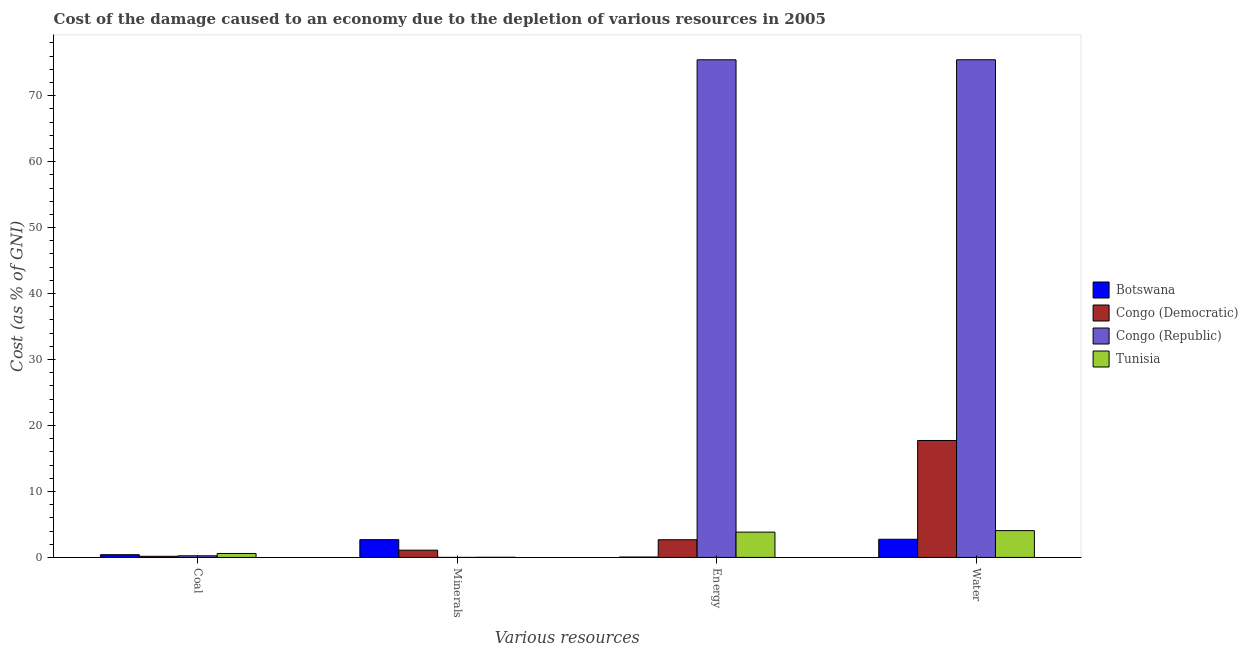Are the number of bars on each tick of the X-axis equal?
Offer a terse response. Yes. How many bars are there on the 1st tick from the left?
Provide a short and direct response. 4. What is the label of the 4th group of bars from the left?
Ensure brevity in your answer.  Water. What is the cost of damage due to depletion of energy in Botswana?
Your answer should be very brief. 0.06. Across all countries, what is the maximum cost of damage due to depletion of minerals?
Give a very brief answer. 2.69. Across all countries, what is the minimum cost of damage due to depletion of coal?
Your answer should be compact. 0.18. In which country was the cost of damage due to depletion of coal maximum?
Your answer should be compact. Tunisia. In which country was the cost of damage due to depletion of minerals minimum?
Give a very brief answer. Congo (Republic). What is the total cost of damage due to depletion of energy in the graph?
Make the answer very short. 82.02. What is the difference between the cost of damage due to depletion of minerals in Congo (Republic) and that in Congo (Democratic)?
Provide a succinct answer. -1.09. What is the difference between the cost of damage due to depletion of coal in Congo (Republic) and the cost of damage due to depletion of water in Botswana?
Make the answer very short. -2.5. What is the average cost of damage due to depletion of minerals per country?
Offer a terse response. 0.95. What is the difference between the cost of damage due to depletion of water and cost of damage due to depletion of energy in Tunisia?
Make the answer very short. 0.23. In how many countries, is the cost of damage due to depletion of energy greater than 44 %?
Your response must be concise. 1. What is the ratio of the cost of damage due to depletion of minerals in Congo (Republic) to that in Congo (Democratic)?
Offer a terse response. 0. Is the cost of damage due to depletion of water in Botswana less than that in Congo (Republic)?
Your response must be concise. Yes. What is the difference between the highest and the second highest cost of damage due to depletion of minerals?
Keep it short and to the point. 1.59. What is the difference between the highest and the lowest cost of damage due to depletion of energy?
Give a very brief answer. 75.38. Is the sum of the cost of damage due to depletion of water in Tunisia and Botswana greater than the maximum cost of damage due to depletion of coal across all countries?
Offer a terse response. Yes. What does the 1st bar from the left in Minerals represents?
Ensure brevity in your answer.  Botswana. What does the 3rd bar from the right in Energy represents?
Give a very brief answer. Congo (Democratic). How many bars are there?
Keep it short and to the point. 16. Are all the bars in the graph horizontal?
Offer a terse response. No. What is the difference between two consecutive major ticks on the Y-axis?
Your answer should be compact. 10. Where does the legend appear in the graph?
Your answer should be very brief. Center right. How many legend labels are there?
Ensure brevity in your answer.  4. What is the title of the graph?
Provide a short and direct response. Cost of the damage caused to an economy due to the depletion of various resources in 2005 . What is the label or title of the X-axis?
Your answer should be compact. Various resources. What is the label or title of the Y-axis?
Give a very brief answer. Cost (as % of GNI). What is the Cost (as % of GNI) in Botswana in Coal?
Your answer should be very brief. 0.41. What is the Cost (as % of GNI) in Congo (Democratic) in Coal?
Your answer should be very brief. 0.18. What is the Cost (as % of GNI) in Congo (Republic) in Coal?
Ensure brevity in your answer.  0.25. What is the Cost (as % of GNI) of Tunisia in Coal?
Ensure brevity in your answer.  0.6. What is the Cost (as % of GNI) in Botswana in Minerals?
Give a very brief answer. 2.69. What is the Cost (as % of GNI) in Congo (Democratic) in Minerals?
Your response must be concise. 1.1. What is the Cost (as % of GNI) of Congo (Republic) in Minerals?
Your response must be concise. 0. What is the Cost (as % of GNI) in Tunisia in Minerals?
Your response must be concise. 0.02. What is the Cost (as % of GNI) in Botswana in Energy?
Offer a very short reply. 0.06. What is the Cost (as % of GNI) of Congo (Democratic) in Energy?
Provide a succinct answer. 2.68. What is the Cost (as % of GNI) in Congo (Republic) in Energy?
Provide a succinct answer. 75.44. What is the Cost (as % of GNI) of Tunisia in Energy?
Your answer should be compact. 3.84. What is the Cost (as % of GNI) of Botswana in Water?
Offer a terse response. 2.75. What is the Cost (as % of GNI) of Congo (Democratic) in Water?
Offer a very short reply. 17.73. What is the Cost (as % of GNI) of Congo (Republic) in Water?
Offer a terse response. 75.44. What is the Cost (as % of GNI) in Tunisia in Water?
Ensure brevity in your answer.  4.06. Across all Various resources, what is the maximum Cost (as % of GNI) of Botswana?
Provide a short and direct response. 2.75. Across all Various resources, what is the maximum Cost (as % of GNI) in Congo (Democratic)?
Ensure brevity in your answer.  17.73. Across all Various resources, what is the maximum Cost (as % of GNI) of Congo (Republic)?
Your answer should be very brief. 75.44. Across all Various resources, what is the maximum Cost (as % of GNI) of Tunisia?
Your response must be concise. 4.06. Across all Various resources, what is the minimum Cost (as % of GNI) of Botswana?
Make the answer very short. 0.06. Across all Various resources, what is the minimum Cost (as % of GNI) in Congo (Democratic)?
Your answer should be very brief. 0.18. Across all Various resources, what is the minimum Cost (as % of GNI) in Congo (Republic)?
Your response must be concise. 0. Across all Various resources, what is the minimum Cost (as % of GNI) of Tunisia?
Provide a succinct answer. 0.02. What is the total Cost (as % of GNI) of Botswana in the graph?
Give a very brief answer. 5.91. What is the total Cost (as % of GNI) of Congo (Democratic) in the graph?
Your response must be concise. 21.68. What is the total Cost (as % of GNI) of Congo (Republic) in the graph?
Your response must be concise. 151.14. What is the total Cost (as % of GNI) of Tunisia in the graph?
Provide a short and direct response. 8.52. What is the difference between the Cost (as % of GNI) in Botswana in Coal and that in Minerals?
Provide a succinct answer. -2.28. What is the difference between the Cost (as % of GNI) of Congo (Democratic) in Coal and that in Minerals?
Your answer should be compact. -0.92. What is the difference between the Cost (as % of GNI) of Congo (Republic) in Coal and that in Minerals?
Make the answer very short. 0.24. What is the difference between the Cost (as % of GNI) in Tunisia in Coal and that in Minerals?
Keep it short and to the point. 0.58. What is the difference between the Cost (as % of GNI) of Botswana in Coal and that in Energy?
Give a very brief answer. 0.35. What is the difference between the Cost (as % of GNI) in Congo (Democratic) in Coal and that in Energy?
Provide a short and direct response. -2.5. What is the difference between the Cost (as % of GNI) in Congo (Republic) in Coal and that in Energy?
Your answer should be compact. -75.19. What is the difference between the Cost (as % of GNI) in Tunisia in Coal and that in Energy?
Provide a short and direct response. -3.24. What is the difference between the Cost (as % of GNI) in Botswana in Coal and that in Water?
Your answer should be very brief. -2.34. What is the difference between the Cost (as % of GNI) of Congo (Democratic) in Coal and that in Water?
Offer a very short reply. -17.55. What is the difference between the Cost (as % of GNI) in Congo (Republic) in Coal and that in Water?
Make the answer very short. -75.19. What is the difference between the Cost (as % of GNI) in Tunisia in Coal and that in Water?
Provide a short and direct response. -3.46. What is the difference between the Cost (as % of GNI) of Botswana in Minerals and that in Energy?
Keep it short and to the point. 2.63. What is the difference between the Cost (as % of GNI) of Congo (Democratic) in Minerals and that in Energy?
Provide a succinct answer. -1.58. What is the difference between the Cost (as % of GNI) in Congo (Republic) in Minerals and that in Energy?
Your response must be concise. -75.43. What is the difference between the Cost (as % of GNI) in Tunisia in Minerals and that in Energy?
Your answer should be very brief. -3.81. What is the difference between the Cost (as % of GNI) in Botswana in Minerals and that in Water?
Your answer should be compact. -0.06. What is the difference between the Cost (as % of GNI) of Congo (Democratic) in Minerals and that in Water?
Give a very brief answer. -16.63. What is the difference between the Cost (as % of GNI) of Congo (Republic) in Minerals and that in Water?
Provide a succinct answer. -75.44. What is the difference between the Cost (as % of GNI) in Tunisia in Minerals and that in Water?
Your answer should be very brief. -4.04. What is the difference between the Cost (as % of GNI) of Botswana in Energy and that in Water?
Offer a very short reply. -2.69. What is the difference between the Cost (as % of GNI) in Congo (Democratic) in Energy and that in Water?
Your answer should be very brief. -15.05. What is the difference between the Cost (as % of GNI) of Congo (Republic) in Energy and that in Water?
Offer a very short reply. -0. What is the difference between the Cost (as % of GNI) of Tunisia in Energy and that in Water?
Give a very brief answer. -0.23. What is the difference between the Cost (as % of GNI) of Botswana in Coal and the Cost (as % of GNI) of Congo (Democratic) in Minerals?
Keep it short and to the point. -0.69. What is the difference between the Cost (as % of GNI) of Botswana in Coal and the Cost (as % of GNI) of Congo (Republic) in Minerals?
Ensure brevity in your answer.  0.41. What is the difference between the Cost (as % of GNI) in Botswana in Coal and the Cost (as % of GNI) in Tunisia in Minerals?
Keep it short and to the point. 0.39. What is the difference between the Cost (as % of GNI) of Congo (Democratic) in Coal and the Cost (as % of GNI) of Congo (Republic) in Minerals?
Your answer should be compact. 0.17. What is the difference between the Cost (as % of GNI) of Congo (Democratic) in Coal and the Cost (as % of GNI) of Tunisia in Minerals?
Offer a terse response. 0.15. What is the difference between the Cost (as % of GNI) in Congo (Republic) in Coal and the Cost (as % of GNI) in Tunisia in Minerals?
Your answer should be compact. 0.23. What is the difference between the Cost (as % of GNI) in Botswana in Coal and the Cost (as % of GNI) in Congo (Democratic) in Energy?
Offer a terse response. -2.27. What is the difference between the Cost (as % of GNI) in Botswana in Coal and the Cost (as % of GNI) in Congo (Republic) in Energy?
Ensure brevity in your answer.  -75.03. What is the difference between the Cost (as % of GNI) in Botswana in Coal and the Cost (as % of GNI) in Tunisia in Energy?
Ensure brevity in your answer.  -3.43. What is the difference between the Cost (as % of GNI) of Congo (Democratic) in Coal and the Cost (as % of GNI) of Congo (Republic) in Energy?
Your answer should be compact. -75.26. What is the difference between the Cost (as % of GNI) in Congo (Democratic) in Coal and the Cost (as % of GNI) in Tunisia in Energy?
Provide a succinct answer. -3.66. What is the difference between the Cost (as % of GNI) in Congo (Republic) in Coal and the Cost (as % of GNI) in Tunisia in Energy?
Provide a succinct answer. -3.59. What is the difference between the Cost (as % of GNI) of Botswana in Coal and the Cost (as % of GNI) of Congo (Democratic) in Water?
Your answer should be very brief. -17.32. What is the difference between the Cost (as % of GNI) of Botswana in Coal and the Cost (as % of GNI) of Congo (Republic) in Water?
Provide a succinct answer. -75.03. What is the difference between the Cost (as % of GNI) in Botswana in Coal and the Cost (as % of GNI) in Tunisia in Water?
Your answer should be compact. -3.65. What is the difference between the Cost (as % of GNI) of Congo (Democratic) in Coal and the Cost (as % of GNI) of Congo (Republic) in Water?
Ensure brevity in your answer.  -75.27. What is the difference between the Cost (as % of GNI) of Congo (Democratic) in Coal and the Cost (as % of GNI) of Tunisia in Water?
Your answer should be very brief. -3.89. What is the difference between the Cost (as % of GNI) in Congo (Republic) in Coal and the Cost (as % of GNI) in Tunisia in Water?
Your response must be concise. -3.81. What is the difference between the Cost (as % of GNI) in Botswana in Minerals and the Cost (as % of GNI) in Congo (Democratic) in Energy?
Your answer should be very brief. 0.01. What is the difference between the Cost (as % of GNI) of Botswana in Minerals and the Cost (as % of GNI) of Congo (Republic) in Energy?
Offer a very short reply. -72.75. What is the difference between the Cost (as % of GNI) of Botswana in Minerals and the Cost (as % of GNI) of Tunisia in Energy?
Keep it short and to the point. -1.15. What is the difference between the Cost (as % of GNI) of Congo (Democratic) in Minerals and the Cost (as % of GNI) of Congo (Republic) in Energy?
Provide a short and direct response. -74.34. What is the difference between the Cost (as % of GNI) of Congo (Democratic) in Minerals and the Cost (as % of GNI) of Tunisia in Energy?
Give a very brief answer. -2.74. What is the difference between the Cost (as % of GNI) in Congo (Republic) in Minerals and the Cost (as % of GNI) in Tunisia in Energy?
Make the answer very short. -3.83. What is the difference between the Cost (as % of GNI) in Botswana in Minerals and the Cost (as % of GNI) in Congo (Democratic) in Water?
Make the answer very short. -15.04. What is the difference between the Cost (as % of GNI) in Botswana in Minerals and the Cost (as % of GNI) in Congo (Republic) in Water?
Your response must be concise. -72.75. What is the difference between the Cost (as % of GNI) in Botswana in Minerals and the Cost (as % of GNI) in Tunisia in Water?
Give a very brief answer. -1.37. What is the difference between the Cost (as % of GNI) of Congo (Democratic) in Minerals and the Cost (as % of GNI) of Congo (Republic) in Water?
Keep it short and to the point. -74.35. What is the difference between the Cost (as % of GNI) in Congo (Democratic) in Minerals and the Cost (as % of GNI) in Tunisia in Water?
Offer a very short reply. -2.97. What is the difference between the Cost (as % of GNI) in Congo (Republic) in Minerals and the Cost (as % of GNI) in Tunisia in Water?
Keep it short and to the point. -4.06. What is the difference between the Cost (as % of GNI) in Botswana in Energy and the Cost (as % of GNI) in Congo (Democratic) in Water?
Your answer should be very brief. -17.67. What is the difference between the Cost (as % of GNI) of Botswana in Energy and the Cost (as % of GNI) of Congo (Republic) in Water?
Provide a succinct answer. -75.38. What is the difference between the Cost (as % of GNI) of Botswana in Energy and the Cost (as % of GNI) of Tunisia in Water?
Ensure brevity in your answer.  -4. What is the difference between the Cost (as % of GNI) in Congo (Democratic) in Energy and the Cost (as % of GNI) in Congo (Republic) in Water?
Make the answer very short. -72.77. What is the difference between the Cost (as % of GNI) in Congo (Democratic) in Energy and the Cost (as % of GNI) in Tunisia in Water?
Provide a succinct answer. -1.38. What is the difference between the Cost (as % of GNI) of Congo (Republic) in Energy and the Cost (as % of GNI) of Tunisia in Water?
Your response must be concise. 71.38. What is the average Cost (as % of GNI) of Botswana per Various resources?
Your response must be concise. 1.48. What is the average Cost (as % of GNI) in Congo (Democratic) per Various resources?
Your answer should be compact. 5.42. What is the average Cost (as % of GNI) of Congo (Republic) per Various resources?
Your answer should be compact. 37.78. What is the average Cost (as % of GNI) of Tunisia per Various resources?
Provide a succinct answer. 2.13. What is the difference between the Cost (as % of GNI) in Botswana and Cost (as % of GNI) in Congo (Democratic) in Coal?
Offer a terse response. 0.24. What is the difference between the Cost (as % of GNI) of Botswana and Cost (as % of GNI) of Congo (Republic) in Coal?
Offer a terse response. 0.16. What is the difference between the Cost (as % of GNI) of Botswana and Cost (as % of GNI) of Tunisia in Coal?
Make the answer very short. -0.19. What is the difference between the Cost (as % of GNI) of Congo (Democratic) and Cost (as % of GNI) of Congo (Republic) in Coal?
Provide a succinct answer. -0.07. What is the difference between the Cost (as % of GNI) in Congo (Democratic) and Cost (as % of GNI) in Tunisia in Coal?
Keep it short and to the point. -0.42. What is the difference between the Cost (as % of GNI) in Congo (Republic) and Cost (as % of GNI) in Tunisia in Coal?
Keep it short and to the point. -0.35. What is the difference between the Cost (as % of GNI) of Botswana and Cost (as % of GNI) of Congo (Democratic) in Minerals?
Keep it short and to the point. 1.59. What is the difference between the Cost (as % of GNI) of Botswana and Cost (as % of GNI) of Congo (Republic) in Minerals?
Offer a very short reply. 2.69. What is the difference between the Cost (as % of GNI) in Botswana and Cost (as % of GNI) in Tunisia in Minerals?
Provide a short and direct response. 2.67. What is the difference between the Cost (as % of GNI) of Congo (Democratic) and Cost (as % of GNI) of Congo (Republic) in Minerals?
Offer a very short reply. 1.09. What is the difference between the Cost (as % of GNI) of Congo (Democratic) and Cost (as % of GNI) of Tunisia in Minerals?
Provide a short and direct response. 1.07. What is the difference between the Cost (as % of GNI) of Congo (Republic) and Cost (as % of GNI) of Tunisia in Minerals?
Offer a terse response. -0.02. What is the difference between the Cost (as % of GNI) of Botswana and Cost (as % of GNI) of Congo (Democratic) in Energy?
Your response must be concise. -2.62. What is the difference between the Cost (as % of GNI) of Botswana and Cost (as % of GNI) of Congo (Republic) in Energy?
Provide a short and direct response. -75.38. What is the difference between the Cost (as % of GNI) in Botswana and Cost (as % of GNI) in Tunisia in Energy?
Provide a succinct answer. -3.78. What is the difference between the Cost (as % of GNI) of Congo (Democratic) and Cost (as % of GNI) of Congo (Republic) in Energy?
Keep it short and to the point. -72.76. What is the difference between the Cost (as % of GNI) of Congo (Democratic) and Cost (as % of GNI) of Tunisia in Energy?
Offer a terse response. -1.16. What is the difference between the Cost (as % of GNI) of Congo (Republic) and Cost (as % of GNI) of Tunisia in Energy?
Your answer should be very brief. 71.6. What is the difference between the Cost (as % of GNI) in Botswana and Cost (as % of GNI) in Congo (Democratic) in Water?
Provide a short and direct response. -14.98. What is the difference between the Cost (as % of GNI) in Botswana and Cost (as % of GNI) in Congo (Republic) in Water?
Keep it short and to the point. -72.69. What is the difference between the Cost (as % of GNI) of Botswana and Cost (as % of GNI) of Tunisia in Water?
Provide a succinct answer. -1.31. What is the difference between the Cost (as % of GNI) in Congo (Democratic) and Cost (as % of GNI) in Congo (Republic) in Water?
Keep it short and to the point. -57.72. What is the difference between the Cost (as % of GNI) in Congo (Democratic) and Cost (as % of GNI) in Tunisia in Water?
Your answer should be very brief. 13.66. What is the difference between the Cost (as % of GNI) in Congo (Republic) and Cost (as % of GNI) in Tunisia in Water?
Give a very brief answer. 71.38. What is the ratio of the Cost (as % of GNI) in Botswana in Coal to that in Minerals?
Make the answer very short. 0.15. What is the ratio of the Cost (as % of GNI) of Congo (Democratic) in Coal to that in Minerals?
Offer a very short reply. 0.16. What is the ratio of the Cost (as % of GNI) of Congo (Republic) in Coal to that in Minerals?
Provide a short and direct response. 52.63. What is the ratio of the Cost (as % of GNI) of Tunisia in Coal to that in Minerals?
Your answer should be very brief. 26.46. What is the ratio of the Cost (as % of GNI) of Botswana in Coal to that in Energy?
Keep it short and to the point. 6.76. What is the ratio of the Cost (as % of GNI) in Congo (Democratic) in Coal to that in Energy?
Your response must be concise. 0.07. What is the ratio of the Cost (as % of GNI) in Congo (Republic) in Coal to that in Energy?
Make the answer very short. 0. What is the ratio of the Cost (as % of GNI) of Tunisia in Coal to that in Energy?
Provide a succinct answer. 0.16. What is the ratio of the Cost (as % of GNI) of Botswana in Coal to that in Water?
Make the answer very short. 0.15. What is the ratio of the Cost (as % of GNI) in Congo (Democratic) in Coal to that in Water?
Make the answer very short. 0.01. What is the ratio of the Cost (as % of GNI) of Congo (Republic) in Coal to that in Water?
Provide a succinct answer. 0. What is the ratio of the Cost (as % of GNI) in Tunisia in Coal to that in Water?
Your answer should be very brief. 0.15. What is the ratio of the Cost (as % of GNI) in Botswana in Minerals to that in Energy?
Offer a very short reply. 44.23. What is the ratio of the Cost (as % of GNI) in Congo (Democratic) in Minerals to that in Energy?
Your response must be concise. 0.41. What is the ratio of the Cost (as % of GNI) in Tunisia in Minerals to that in Energy?
Your answer should be compact. 0.01. What is the ratio of the Cost (as % of GNI) in Botswana in Minerals to that in Water?
Offer a terse response. 0.98. What is the ratio of the Cost (as % of GNI) of Congo (Democratic) in Minerals to that in Water?
Provide a short and direct response. 0.06. What is the ratio of the Cost (as % of GNI) of Tunisia in Minerals to that in Water?
Ensure brevity in your answer.  0.01. What is the ratio of the Cost (as % of GNI) of Botswana in Energy to that in Water?
Your response must be concise. 0.02. What is the ratio of the Cost (as % of GNI) of Congo (Democratic) in Energy to that in Water?
Your response must be concise. 0.15. What is the ratio of the Cost (as % of GNI) of Congo (Republic) in Energy to that in Water?
Ensure brevity in your answer.  1. What is the ratio of the Cost (as % of GNI) in Tunisia in Energy to that in Water?
Ensure brevity in your answer.  0.94. What is the difference between the highest and the second highest Cost (as % of GNI) of Botswana?
Offer a terse response. 0.06. What is the difference between the highest and the second highest Cost (as % of GNI) of Congo (Democratic)?
Your answer should be compact. 15.05. What is the difference between the highest and the second highest Cost (as % of GNI) in Congo (Republic)?
Keep it short and to the point. 0. What is the difference between the highest and the second highest Cost (as % of GNI) in Tunisia?
Offer a terse response. 0.23. What is the difference between the highest and the lowest Cost (as % of GNI) in Botswana?
Give a very brief answer. 2.69. What is the difference between the highest and the lowest Cost (as % of GNI) in Congo (Democratic)?
Your response must be concise. 17.55. What is the difference between the highest and the lowest Cost (as % of GNI) in Congo (Republic)?
Your response must be concise. 75.44. What is the difference between the highest and the lowest Cost (as % of GNI) of Tunisia?
Your answer should be compact. 4.04. 